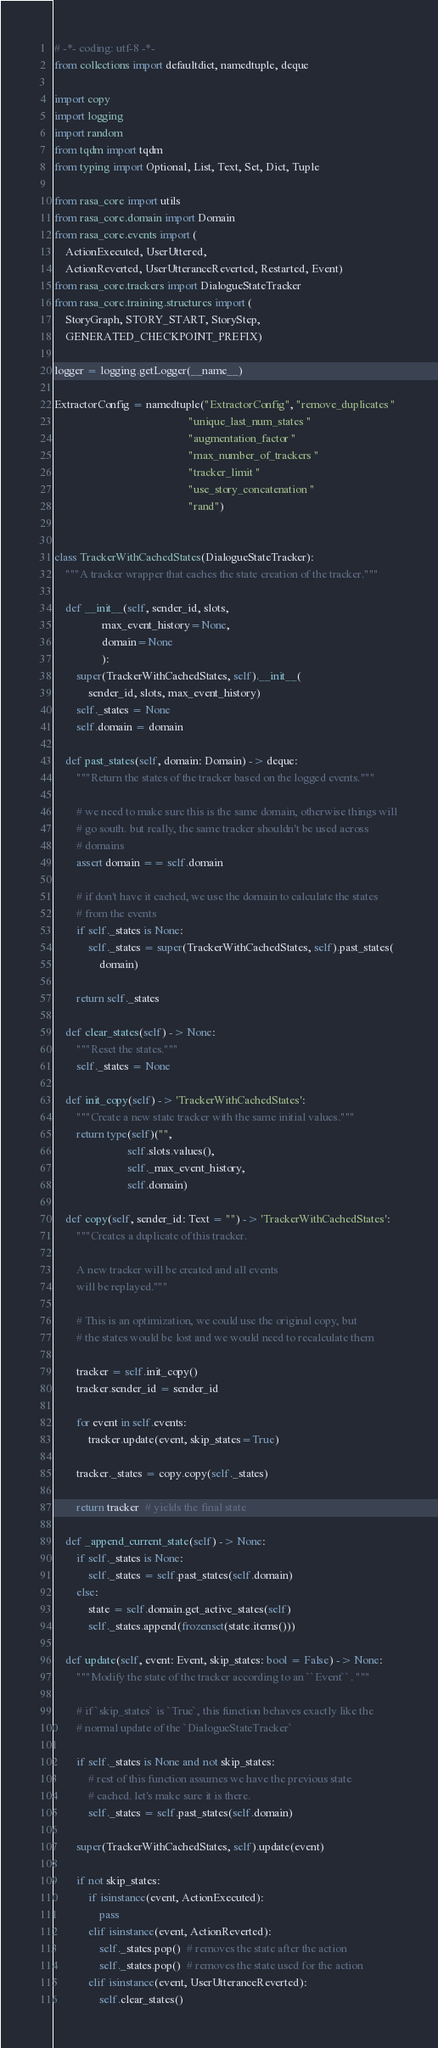<code> <loc_0><loc_0><loc_500><loc_500><_Python_># -*- coding: utf-8 -*-
from collections import defaultdict, namedtuple, deque

import copy
import logging
import random
from tqdm import tqdm
from typing import Optional, List, Text, Set, Dict, Tuple

from rasa_core import utils
from rasa_core.domain import Domain
from rasa_core.events import (
    ActionExecuted, UserUttered,
    ActionReverted, UserUtteranceReverted, Restarted, Event)
from rasa_core.trackers import DialogueStateTracker
from rasa_core.training.structures import (
    StoryGraph, STORY_START, StoryStep,
    GENERATED_CHECKPOINT_PREFIX)

logger = logging.getLogger(__name__)

ExtractorConfig = namedtuple("ExtractorConfig", "remove_duplicates "
                                                "unique_last_num_states "
                                                "augmentation_factor "
                                                "max_number_of_trackers "
                                                "tracker_limit "
                                                "use_story_concatenation "
                                                "rand")


class TrackerWithCachedStates(DialogueStateTracker):
    """A tracker wrapper that caches the state creation of the tracker."""

    def __init__(self, sender_id, slots,
                 max_event_history=None,
                 domain=None
                 ):
        super(TrackerWithCachedStates, self).__init__(
            sender_id, slots, max_event_history)
        self._states = None
        self.domain = domain

    def past_states(self, domain: Domain) -> deque:
        """Return the states of the tracker based on the logged events."""

        # we need to make sure this is the same domain, otherwise things will
        # go south. but really, the same tracker shouldn't be used across
        # domains
        assert domain == self.domain

        # if don't have it cached, we use the domain to calculate the states
        # from the events
        if self._states is None:
            self._states = super(TrackerWithCachedStates, self).past_states(
                domain)

        return self._states

    def clear_states(self) -> None:
        """Reset the states."""
        self._states = None

    def init_copy(self) -> 'TrackerWithCachedStates':
        """Create a new state tracker with the same initial values."""
        return type(self)("",
                          self.slots.values(),
                          self._max_event_history,
                          self.domain)

    def copy(self, sender_id: Text = "") -> 'TrackerWithCachedStates':
        """Creates a duplicate of this tracker.

        A new tracker will be created and all events
        will be replayed."""

        # This is an optimization, we could use the original copy, but
        # the states would be lost and we would need to recalculate them

        tracker = self.init_copy()
        tracker.sender_id = sender_id

        for event in self.events:
            tracker.update(event, skip_states=True)

        tracker._states = copy.copy(self._states)

        return tracker  # yields the final state

    def _append_current_state(self) -> None:
        if self._states is None:
            self._states = self.past_states(self.domain)
        else:
            state = self.domain.get_active_states(self)
            self._states.append(frozenset(state.items()))

    def update(self, event: Event, skip_states: bool = False) -> None:
        """Modify the state of the tracker according to an ``Event``. """

        # if `skip_states` is `True`, this function behaves exactly like the
        # normal update of the `DialogueStateTracker`

        if self._states is None and not skip_states:
            # rest of this function assumes we have the previous state
            # cached. let's make sure it is there.
            self._states = self.past_states(self.domain)

        super(TrackerWithCachedStates, self).update(event)

        if not skip_states:
            if isinstance(event, ActionExecuted):
                pass
            elif isinstance(event, ActionReverted):
                self._states.pop()  # removes the state after the action
                self._states.pop()  # removes the state used for the action
            elif isinstance(event, UserUtteranceReverted):
                self.clear_states()</code> 